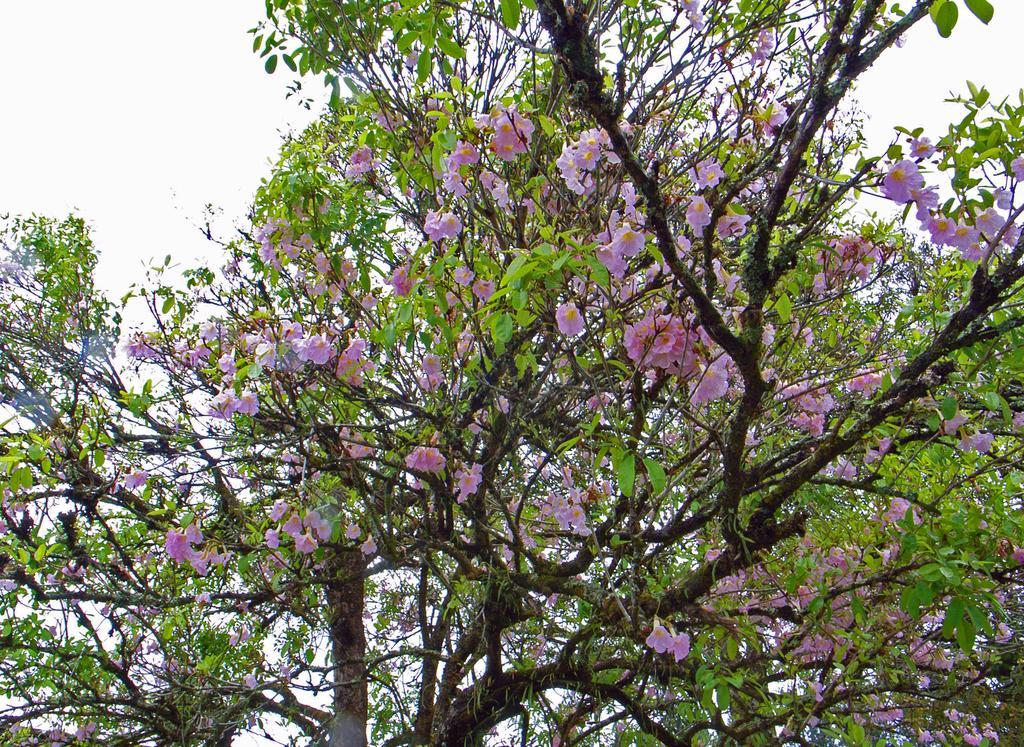Please provide a concise description of this image. In this picture I can see a tree and few flowers and I can see a cloudy sky. 